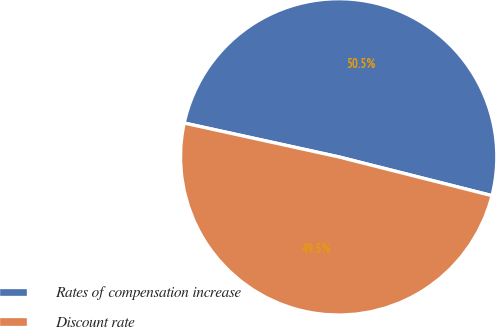Convert chart. <chart><loc_0><loc_0><loc_500><loc_500><pie_chart><fcel>Rates of compensation increase<fcel>Discount rate<nl><fcel>50.51%<fcel>49.49%<nl></chart> 